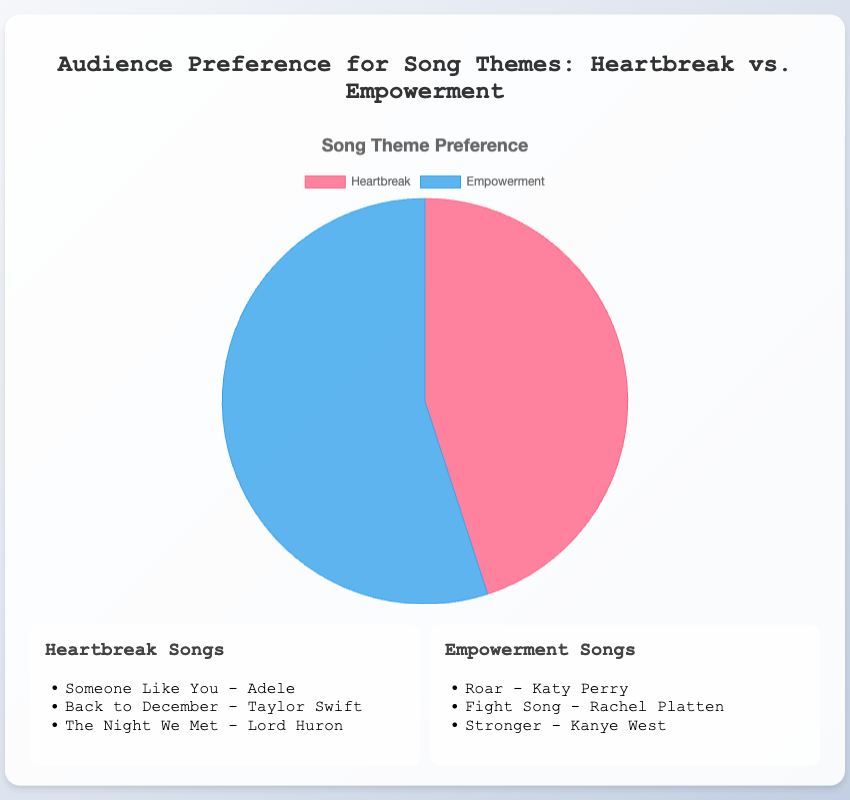What are the two song themes represented in the pie chart? The pie chart shows "Heartbreak" and "Empowerment" as the two song themes.
Answer: Heartbreak and Empowerment Which song theme has a higher percentage of audience preference? The pie chart shows that the "Empowerment" theme has a higher percentage than "Heartbreak".
Answer: Empowerment By how much does the preference for Empowerment songs exceed that for Heartbreak songs? The Empowerment theme has 55% preference while Heartbreak has 45%. The difference is 55% - 45% = 10%.
Answer: 10% What is the total audience preference percentage shown in the pie chart? The total percentage for audience preference is derived by adding the percentages for both themes: 45% + 55% = 100%.
Answer: 100% If 1000 people were surveyed, approximately how many prefer Empowerment songs? Given the percentage for Empowerment is 55%, the number of people preferring Empowerment songs is 55% of 1000, which is 0.55 * 1000 = 550.
Answer: 550 What percentage of the audience prefers Heartbreak songs? The pie chart directly shows that 45% of the audience prefers Heartbreak songs.
Answer: 45% List three examples of Empowerment songs mentioned. The pie chart legend lists "Roar - Katy Perry", "Fight Song - Rachel Platten", and "Stronger - Kanye West" as examples of Empowerment songs.
Answer: Roar - Katy Perry, Fight Song – Rachel Platten, Stronger - Kanye West What visual colors represent Heartbreak and Empowerment themes in the pie chart? The pie chart uses red to represent Heartbreak and blue to represent Empowerment.
Answer: Red and Blue Which theme has a larger slice in the pie chart, visually? The blue slice, representing Empowerment, is larger than the red slice, which represents Heartbreak.
Answer: Empowerment What is the sum of the percentages shown for both song themes? The sum of the percentages for Heartbreak (45%) and Empowerment (55%) is 45% + 55% = 100%.
Answer: 100% 